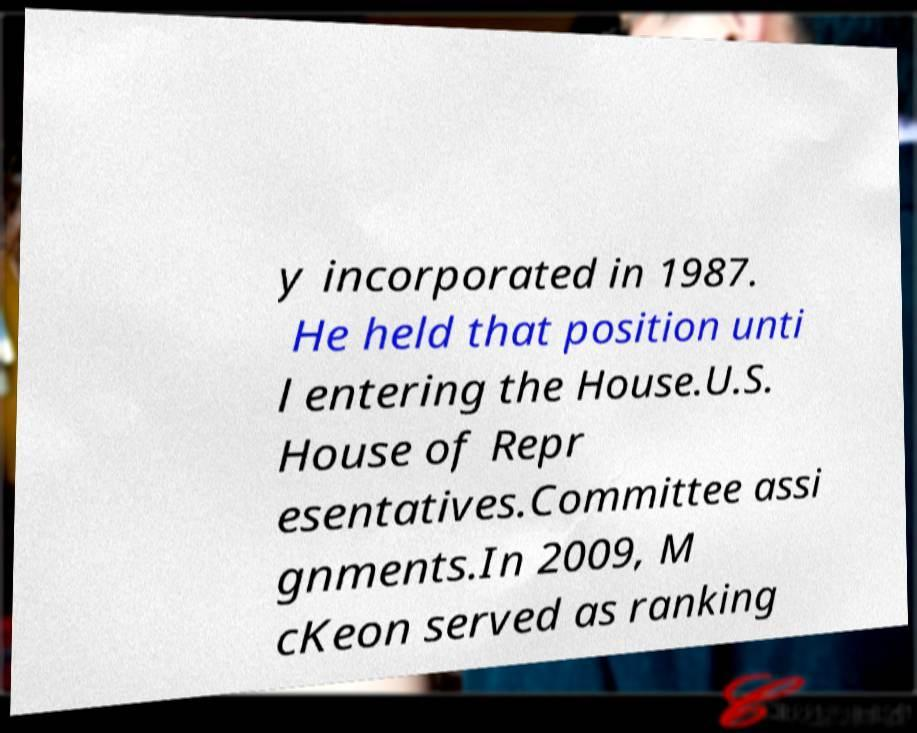For documentation purposes, I need the text within this image transcribed. Could you provide that? y incorporated in 1987. He held that position unti l entering the House.U.S. House of Repr esentatives.Committee assi gnments.In 2009, M cKeon served as ranking 